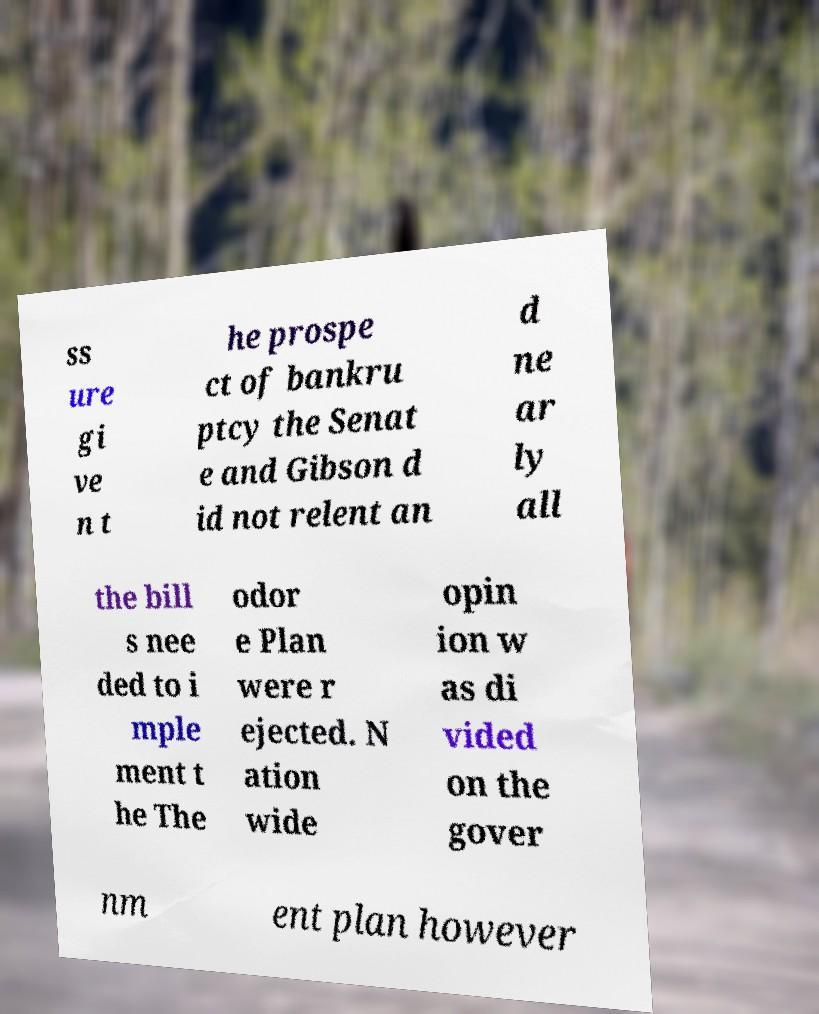Can you accurately transcribe the text from the provided image for me? ss ure gi ve n t he prospe ct of bankru ptcy the Senat e and Gibson d id not relent an d ne ar ly all the bill s nee ded to i mple ment t he The odor e Plan were r ejected. N ation wide opin ion w as di vided on the gover nm ent plan however 